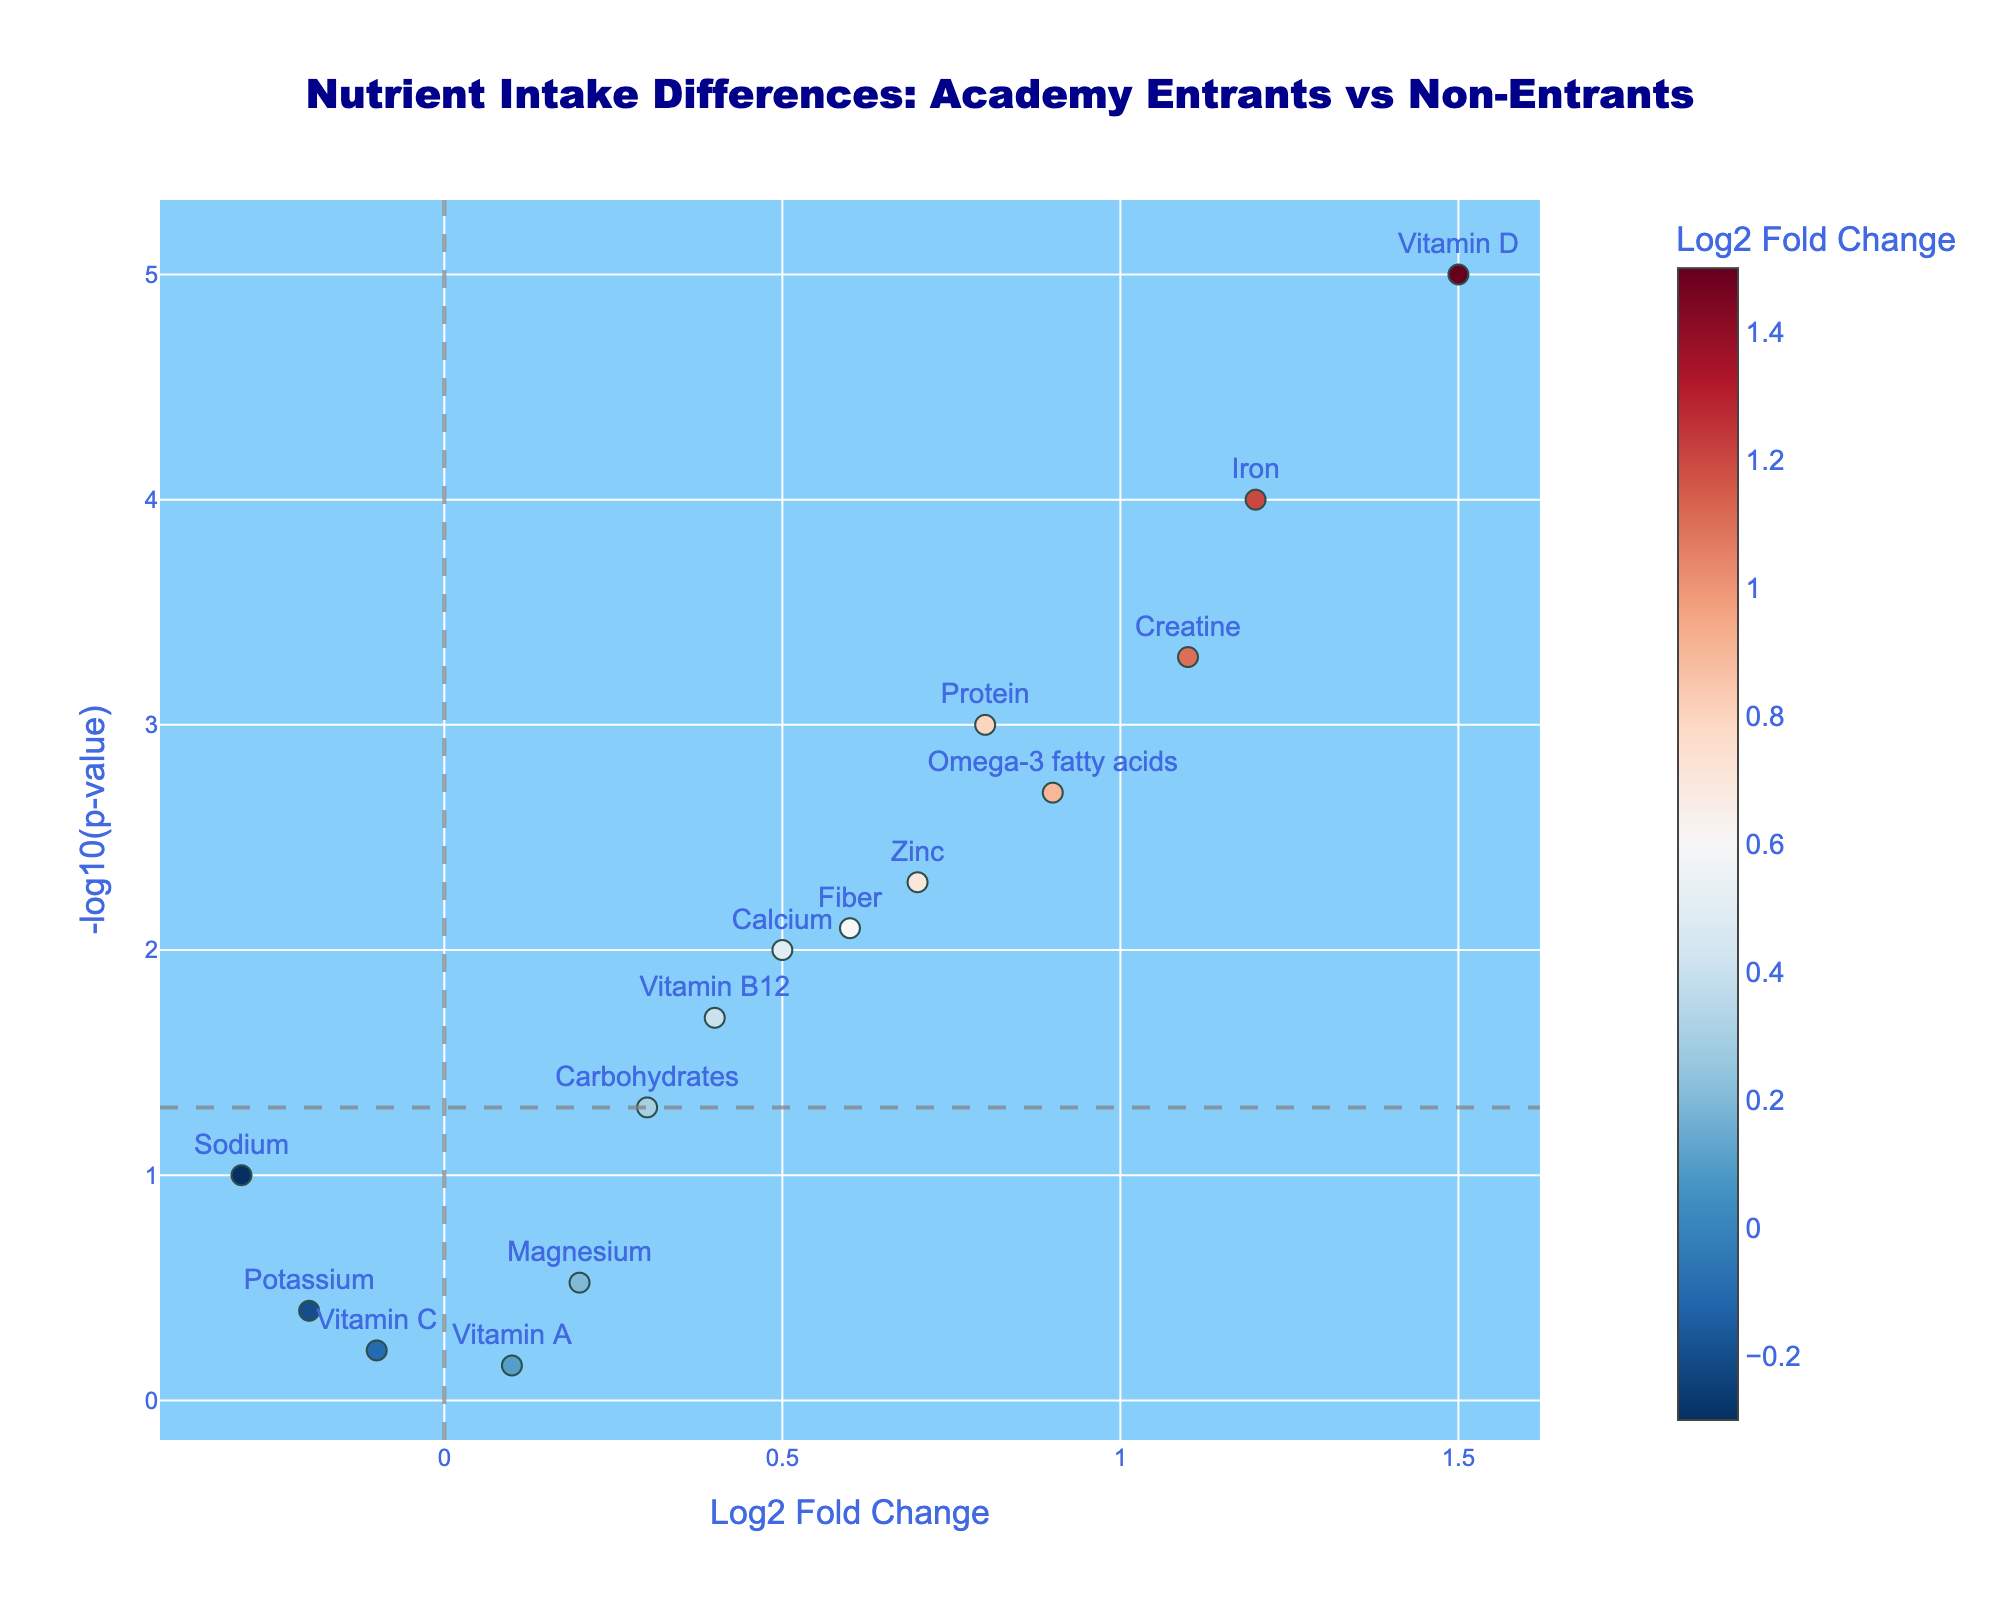What is the title of the plot? The title of the plot is usually located at the top of the figure, and it categorically describes the main content of the plot.
Answer: Nutrient Intake Differences: Academy Entrants vs Non-Entrants How many nutrients have a positive log2 fold change? Count the number of data points that have a log2 fold change greater than 0 on the x-axis.
Answer: 10 Which nutrient has the smallest p-value? The nutrient with the smallest p-value will be the one with the highest value on the y-axis (-log10(p-value)).
Answer: Vitamin D Which nutrients are considered statistically significant? Nutrients with a p-value < 0.05 are considered statistically significant, represented by those above the horizontal line at -log10(0.05) in the plot.
Answer: Protein, Iron, Calcium, Vitamin D, Omega-3 fatty acids, Zinc, Vitamin B12, Fiber, Creatine What are the log2 fold changes of Creatine and Iron? Locate the data points for Creatine and Iron on the x-axis to read their log2 fold changes.
Answer: Creatine: 1.1, Iron: 1.2 Which nutrient besides Vitamin D has the highest log2 fold change? Follow the x-axis to identify the nutrient with the second highest log2 fold change after Vitamin D.
Answer: Iron How is Vitamin C characterized in terms of log2 fold change and significance? Check the position of Vitamin C on the plot to assess its log2 fold change and whether it's below the significance line.
Answer: Log2 fold change is -0.1, not significant (p-value > 0.05) Is there any nutrient with a negative log2 fold change that is statistically significant? Check if any nutrient to the left of zero on the x-axis lies above the significance line.
Answer: No What is the fold change and p-value for Zinc? Locate the data point for Zinc and refer to its hover text or position on the axes to find these values.
Answer: Log2 fold change is 0.7, p-value is 0.005 Which nutrient has the highest log2 fold change but is not statistically significant? Identify the data point with the highest log2 fold change value below the significance threshold.
Answer: Vitamin A 